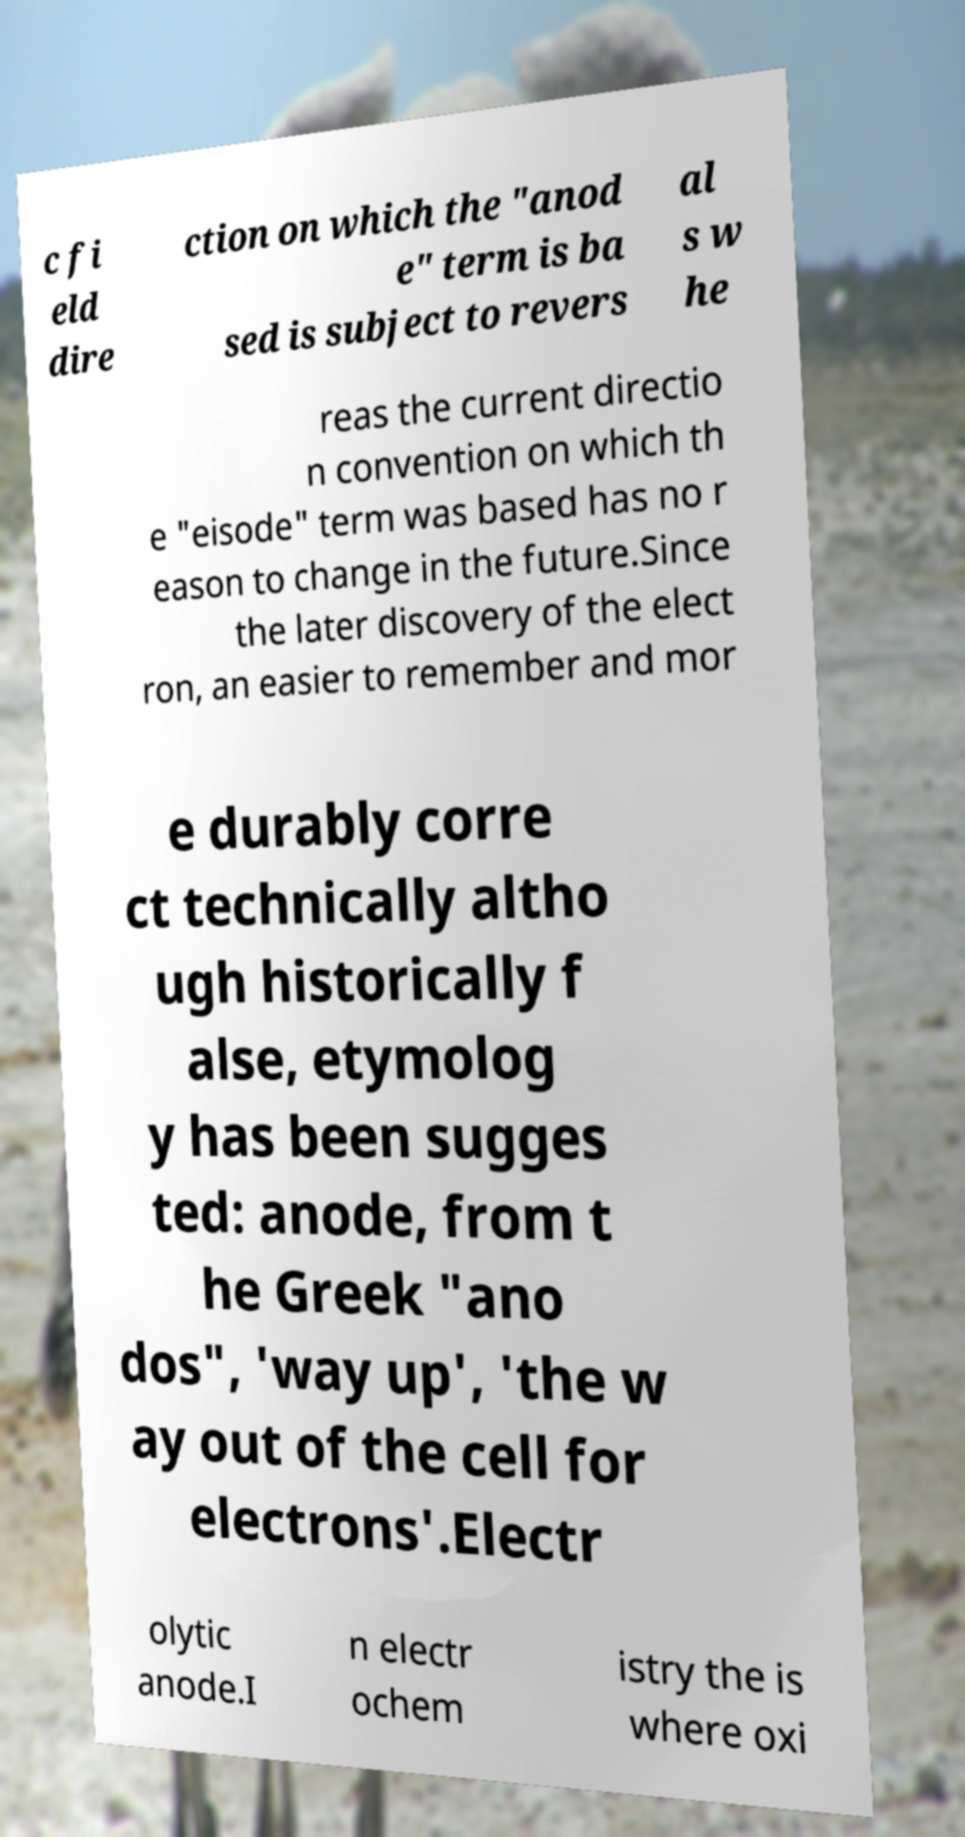Please read and relay the text visible in this image. What does it say? c fi eld dire ction on which the "anod e" term is ba sed is subject to revers al s w he reas the current directio n convention on which th e "eisode" term was based has no r eason to change in the future.Since the later discovery of the elect ron, an easier to remember and mor e durably corre ct technically altho ugh historically f alse, etymolog y has been sugges ted: anode, from t he Greek "ano dos", 'way up', 'the w ay out of the cell for electrons'.Electr olytic anode.I n electr ochem istry the is where oxi 